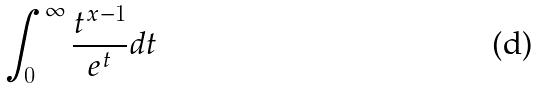<formula> <loc_0><loc_0><loc_500><loc_500>\int _ { 0 } ^ { \infty } \frac { t ^ { x - 1 } } { e ^ { t } } d t</formula> 